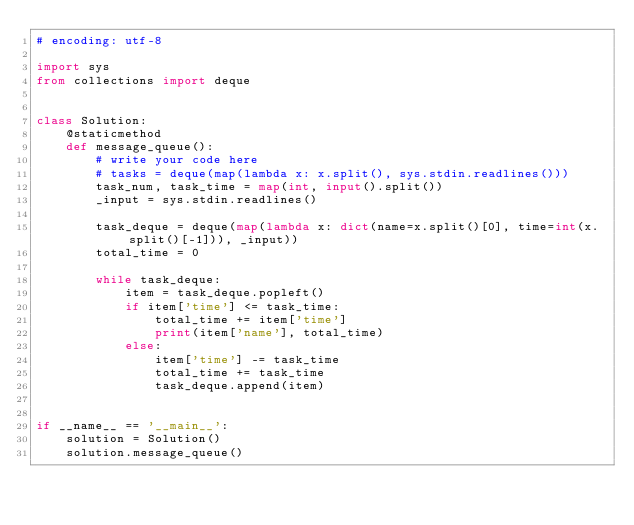<code> <loc_0><loc_0><loc_500><loc_500><_Python_># encoding: utf-8

import sys
from collections import deque


class Solution:
    @staticmethod
    def message_queue():
        # write your code here
        # tasks = deque(map(lambda x: x.split(), sys.stdin.readlines()))
        task_num, task_time = map(int, input().split())
        _input = sys.stdin.readlines()
        
        task_deque = deque(map(lambda x: dict(name=x.split()[0], time=int(x.split()[-1])), _input))
        total_time = 0

        while task_deque:
            item = task_deque.popleft()
            if item['time'] <= task_time:
                total_time += item['time']
                print(item['name'], total_time)
            else:
                item['time'] -= task_time
                total_time += task_time
                task_deque.append(item)


if __name__ == '__main__':
    solution = Solution()
    solution.message_queue()</code> 